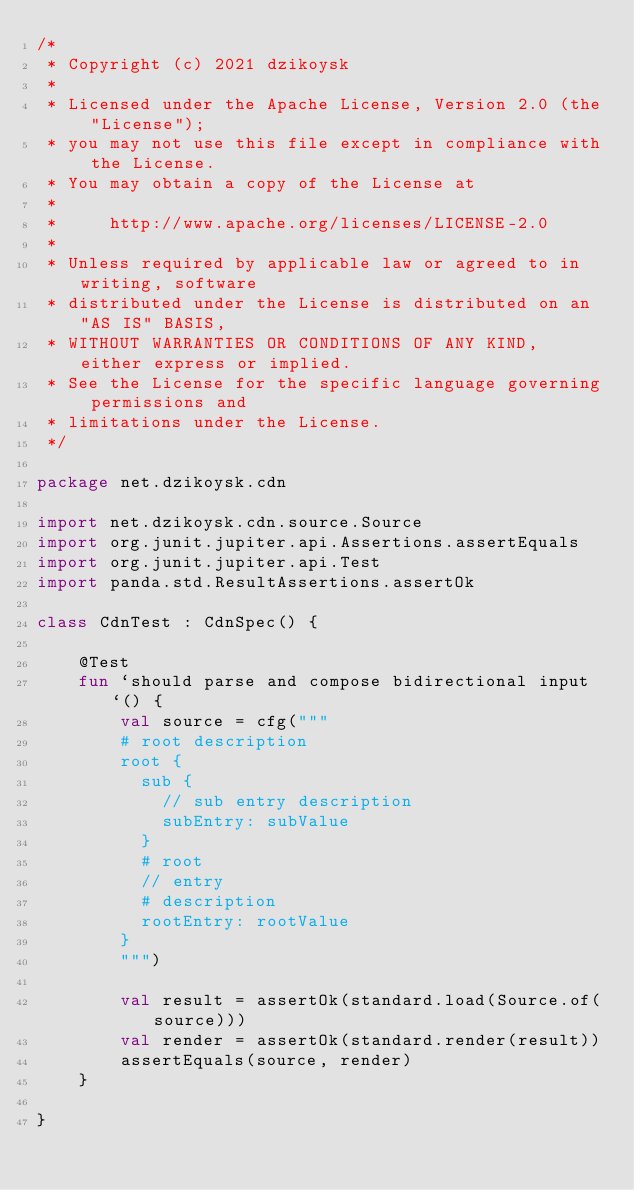<code> <loc_0><loc_0><loc_500><loc_500><_Kotlin_>/*
 * Copyright (c) 2021 dzikoysk
 *
 * Licensed under the Apache License, Version 2.0 (the "License");
 * you may not use this file except in compliance with the License.
 * You may obtain a copy of the License at
 *
 *     http://www.apache.org/licenses/LICENSE-2.0
 *
 * Unless required by applicable law or agreed to in writing, software
 * distributed under the License is distributed on an "AS IS" BASIS,
 * WITHOUT WARRANTIES OR CONDITIONS OF ANY KIND, either express or implied.
 * See the License for the specific language governing permissions and
 * limitations under the License.
 */

package net.dzikoysk.cdn

import net.dzikoysk.cdn.source.Source
import org.junit.jupiter.api.Assertions.assertEquals
import org.junit.jupiter.api.Test
import panda.std.ResultAssertions.assertOk

class CdnTest : CdnSpec() {

    @Test
    fun `should parse and compose bidirectional input`() {
        val source = cfg("""
        # root description
        root {
          sub {
            // sub entry description
            subEntry: subValue
          }
          # root
          // entry
          # description
          rootEntry: rootValue
        }
        """)

        val result = assertOk(standard.load(Source.of(source)))
        val render = assertOk(standard.render(result))
        assertEquals(source, render)
    }

}
</code> 